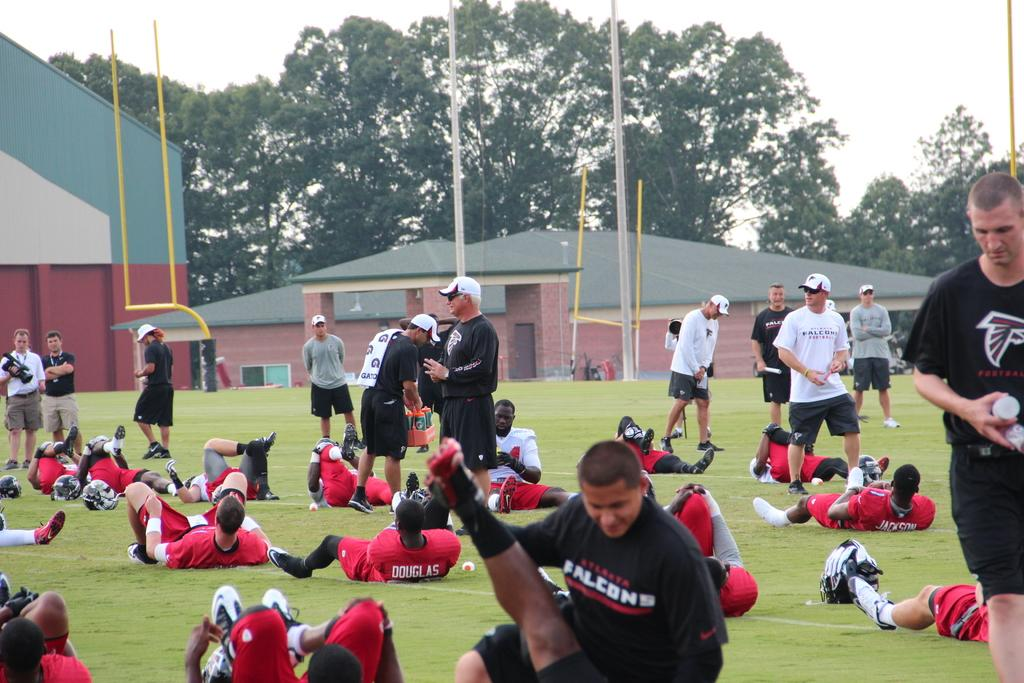<image>
Share a concise interpretation of the image provided. Group of Falcons football players having practice on a sunny day. 